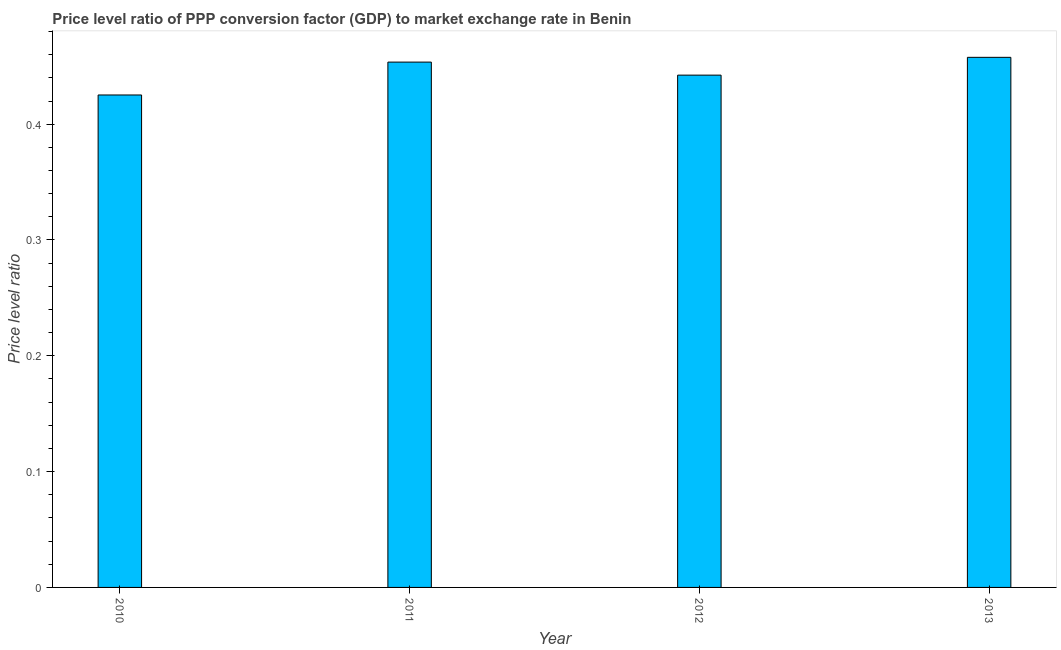Does the graph contain grids?
Offer a terse response. No. What is the title of the graph?
Ensure brevity in your answer.  Price level ratio of PPP conversion factor (GDP) to market exchange rate in Benin. What is the label or title of the X-axis?
Your response must be concise. Year. What is the label or title of the Y-axis?
Give a very brief answer. Price level ratio. What is the price level ratio in 2011?
Your response must be concise. 0.45. Across all years, what is the maximum price level ratio?
Offer a terse response. 0.46. Across all years, what is the minimum price level ratio?
Your answer should be very brief. 0.43. In which year was the price level ratio maximum?
Provide a short and direct response. 2013. What is the sum of the price level ratio?
Offer a terse response. 1.78. What is the difference between the price level ratio in 2010 and 2011?
Give a very brief answer. -0.03. What is the average price level ratio per year?
Your response must be concise. 0.45. What is the median price level ratio?
Keep it short and to the point. 0.45. In how many years, is the price level ratio greater than 0.14 ?
Give a very brief answer. 4. Do a majority of the years between 2010 and 2012 (inclusive) have price level ratio greater than 0.12 ?
Make the answer very short. Yes. What is the ratio of the price level ratio in 2010 to that in 2013?
Offer a very short reply. 0.93. Is the price level ratio in 2010 less than that in 2013?
Keep it short and to the point. Yes. Is the difference between the price level ratio in 2011 and 2012 greater than the difference between any two years?
Offer a terse response. No. What is the difference between the highest and the second highest price level ratio?
Your answer should be very brief. 0. What is the difference between the highest and the lowest price level ratio?
Your answer should be very brief. 0.03. Are all the bars in the graph horizontal?
Your answer should be compact. No. What is the Price level ratio in 2010?
Keep it short and to the point. 0.43. What is the Price level ratio of 2011?
Give a very brief answer. 0.45. What is the Price level ratio in 2012?
Your answer should be very brief. 0.44. What is the Price level ratio in 2013?
Provide a short and direct response. 0.46. What is the difference between the Price level ratio in 2010 and 2011?
Give a very brief answer. -0.03. What is the difference between the Price level ratio in 2010 and 2012?
Provide a succinct answer. -0.02. What is the difference between the Price level ratio in 2010 and 2013?
Your answer should be very brief. -0.03. What is the difference between the Price level ratio in 2011 and 2012?
Offer a terse response. 0.01. What is the difference between the Price level ratio in 2011 and 2013?
Make the answer very short. -0. What is the difference between the Price level ratio in 2012 and 2013?
Offer a terse response. -0.02. What is the ratio of the Price level ratio in 2010 to that in 2011?
Your response must be concise. 0.94. What is the ratio of the Price level ratio in 2010 to that in 2013?
Your response must be concise. 0.93. 